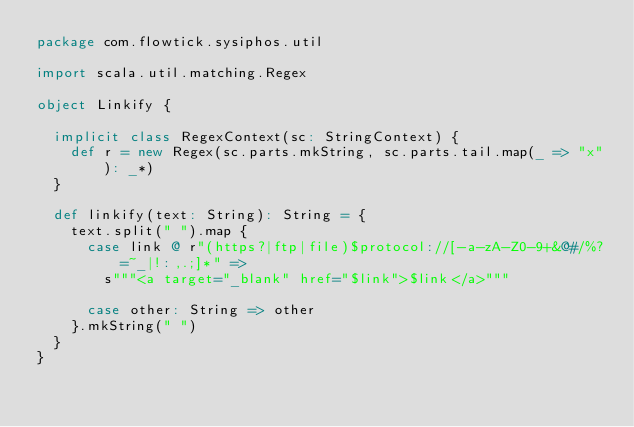<code> <loc_0><loc_0><loc_500><loc_500><_Scala_>package com.flowtick.sysiphos.util

import scala.util.matching.Regex

object Linkify {

  implicit class RegexContext(sc: StringContext) {
    def r = new Regex(sc.parts.mkString, sc.parts.tail.map(_ => "x"): _*)
  }

  def linkify(text: String): String = {
    text.split(" ").map {
      case link @ r"(https?|ftp|file)$protocol://[-a-zA-Z0-9+&@#/%?=~_|!:,.;]*" =>
        s"""<a target="_blank" href="$link">$link</a>"""

      case other: String => other
    }.mkString(" ")
  }
}
</code> 